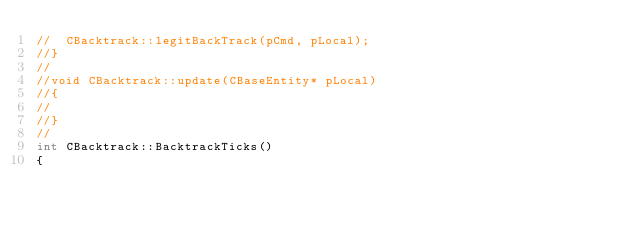<code> <loc_0><loc_0><loc_500><loc_500><_C++_>//	CBacktrack::legitBackTrack(pCmd, pLocal);
//}
//
//void CBacktrack::update(CBaseEntity* pLocal)
//{
//
//}
//
int CBacktrack::BacktrackTicks()
{</code> 